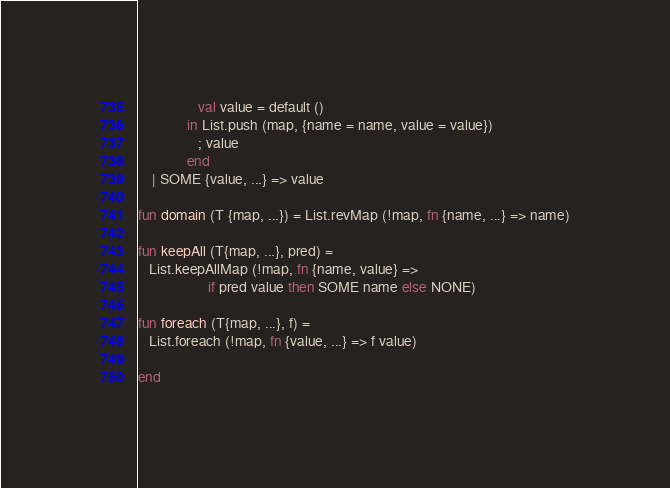<code> <loc_0><loc_0><loc_500><loc_500><_SML_>                 val value = default ()
              in List.push (map, {name = name, value = value})
                 ; value
              end
    | SOME {value, ...} => value

fun domain (T {map, ...}) = List.revMap (!map, fn {name, ...} => name)

fun keepAll (T{map, ...}, pred) = 
   List.keepAllMap (!map, fn {name, value} =>
                    if pred value then SOME name else NONE)

fun foreach (T{map, ...}, f) =
   List.foreach (!map, fn {value, ...} => f value)

end
</code> 